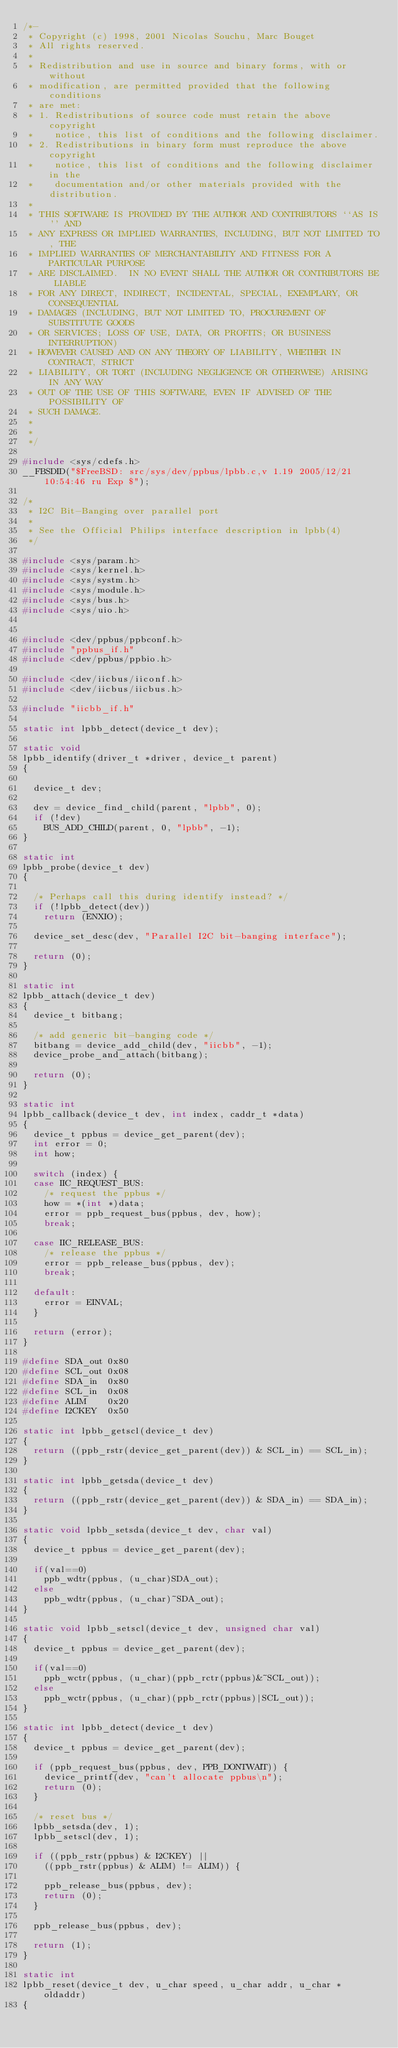Convert code to text. <code><loc_0><loc_0><loc_500><loc_500><_C_>/*-
 * Copyright (c) 1998, 2001 Nicolas Souchu, Marc Bouget
 * All rights reserved.
 *
 * Redistribution and use in source and binary forms, with or without
 * modification, are permitted provided that the following conditions
 * are met:
 * 1. Redistributions of source code must retain the above copyright
 *    notice, this list of conditions and the following disclaimer.
 * 2. Redistributions in binary form must reproduce the above copyright
 *    notice, this list of conditions and the following disclaimer in the
 *    documentation and/or other materials provided with the distribution.
 *
 * THIS SOFTWARE IS PROVIDED BY THE AUTHOR AND CONTRIBUTORS ``AS IS'' AND
 * ANY EXPRESS OR IMPLIED WARRANTIES, INCLUDING, BUT NOT LIMITED TO, THE
 * IMPLIED WARRANTIES OF MERCHANTABILITY AND FITNESS FOR A PARTICULAR PURPOSE
 * ARE DISCLAIMED.  IN NO EVENT SHALL THE AUTHOR OR CONTRIBUTORS BE LIABLE
 * FOR ANY DIRECT, INDIRECT, INCIDENTAL, SPECIAL, EXEMPLARY, OR CONSEQUENTIAL
 * DAMAGES (INCLUDING, BUT NOT LIMITED TO, PROCUREMENT OF SUBSTITUTE GOODS
 * OR SERVICES; LOSS OF USE, DATA, OR PROFITS; OR BUSINESS INTERRUPTION)
 * HOWEVER CAUSED AND ON ANY THEORY OF LIABILITY, WHETHER IN CONTRACT, STRICT
 * LIABILITY, OR TORT (INCLUDING NEGLIGENCE OR OTHERWISE) ARISING IN ANY WAY
 * OUT OF THE USE OF THIS SOFTWARE, EVEN IF ADVISED OF THE POSSIBILITY OF
 * SUCH DAMAGE.
 *
 *
 */

#include <sys/cdefs.h>
__FBSDID("$FreeBSD: src/sys/dev/ppbus/lpbb.c,v 1.19 2005/12/21 10:54:46 ru Exp $");

/*
 * I2C Bit-Banging over parallel port
 *
 * See the Official Philips interface description in lpbb(4)
 */

#include <sys/param.h>
#include <sys/kernel.h>
#include <sys/systm.h>
#include <sys/module.h>
#include <sys/bus.h>
#include <sys/uio.h>


#include <dev/ppbus/ppbconf.h>
#include "ppbus_if.h"
#include <dev/ppbus/ppbio.h>

#include <dev/iicbus/iiconf.h>
#include <dev/iicbus/iicbus.h>

#include "iicbb_if.h"

static int lpbb_detect(device_t dev);

static void
lpbb_identify(driver_t *driver, device_t parent)
{

	device_t dev;

	dev = device_find_child(parent, "lpbb", 0);
	if (!dev)
		BUS_ADD_CHILD(parent, 0, "lpbb", -1);
}

static int
lpbb_probe(device_t dev)
{

	/* Perhaps call this during identify instead? */
	if (!lpbb_detect(dev))
		return (ENXIO);

	device_set_desc(dev, "Parallel I2C bit-banging interface");

	return (0);
}

static int
lpbb_attach(device_t dev)
{
	device_t bitbang;
	
	/* add generic bit-banging code */
	bitbang = device_add_child(dev, "iicbb", -1);
	device_probe_and_attach(bitbang);

	return (0);
}

static int
lpbb_callback(device_t dev, int index, caddr_t *data)
{
	device_t ppbus = device_get_parent(dev);
	int error = 0;
	int how;

	switch (index) {
	case IIC_REQUEST_BUS:
		/* request the ppbus */
		how = *(int *)data;
		error = ppb_request_bus(ppbus, dev, how);
		break;

	case IIC_RELEASE_BUS:
		/* release the ppbus */
		error = ppb_release_bus(ppbus, dev);
		break;

	default:
		error = EINVAL;
	}

	return (error);
}

#define SDA_out 0x80
#define SCL_out 0x08
#define SDA_in  0x80
#define SCL_in  0x08
#define ALIM    0x20
#define I2CKEY  0x50

static int lpbb_getscl(device_t dev)
{
	return ((ppb_rstr(device_get_parent(dev)) & SCL_in) == SCL_in);
}

static int lpbb_getsda(device_t dev)
{
	return ((ppb_rstr(device_get_parent(dev)) & SDA_in) == SDA_in);
}

static void lpbb_setsda(device_t dev, char val)
{
	device_t ppbus = device_get_parent(dev);

	if(val==0)
		ppb_wdtr(ppbus, (u_char)SDA_out);
	else                            
		ppb_wdtr(ppbus, (u_char)~SDA_out);
}

static void lpbb_setscl(device_t dev, unsigned char val)
{
	device_t ppbus = device_get_parent(dev);

	if(val==0)
		ppb_wctr(ppbus, (u_char)(ppb_rctr(ppbus)&~SCL_out));
	else                                               
		ppb_wctr(ppbus, (u_char)(ppb_rctr(ppbus)|SCL_out)); 
}

static int lpbb_detect(device_t dev)
{
	device_t ppbus = device_get_parent(dev);

	if (ppb_request_bus(ppbus, dev, PPB_DONTWAIT)) {
		device_printf(dev, "can't allocate ppbus\n");
		return (0);
	}

	/* reset bus */
	lpbb_setsda(dev, 1);
	lpbb_setscl(dev, 1);

	if ((ppb_rstr(ppbus) & I2CKEY) ||
		((ppb_rstr(ppbus) & ALIM) != ALIM)) {

		ppb_release_bus(ppbus, dev);
		return (0);
	}

	ppb_release_bus(ppbus, dev);

	return (1);
}

static int
lpbb_reset(device_t dev, u_char speed, u_char addr, u_char * oldaddr)
{</code> 